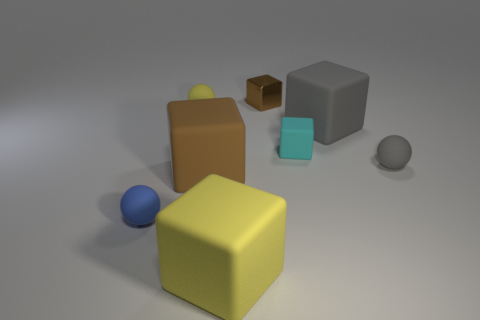Subtract all tiny brown shiny blocks. How many blocks are left? 4 Subtract all yellow blocks. How many blocks are left? 4 Add 2 big yellow rubber cubes. How many objects exist? 10 Subtract all cubes. How many objects are left? 3 Subtract 4 blocks. How many blocks are left? 1 Subtract all brown cubes. Subtract all brown balls. How many cubes are left? 3 Subtract all purple spheres. How many cyan cubes are left? 1 Subtract all blue rubber things. Subtract all tiny purple shiny cubes. How many objects are left? 7 Add 6 tiny gray matte objects. How many tiny gray matte objects are left? 7 Add 1 big red cubes. How many big red cubes exist? 1 